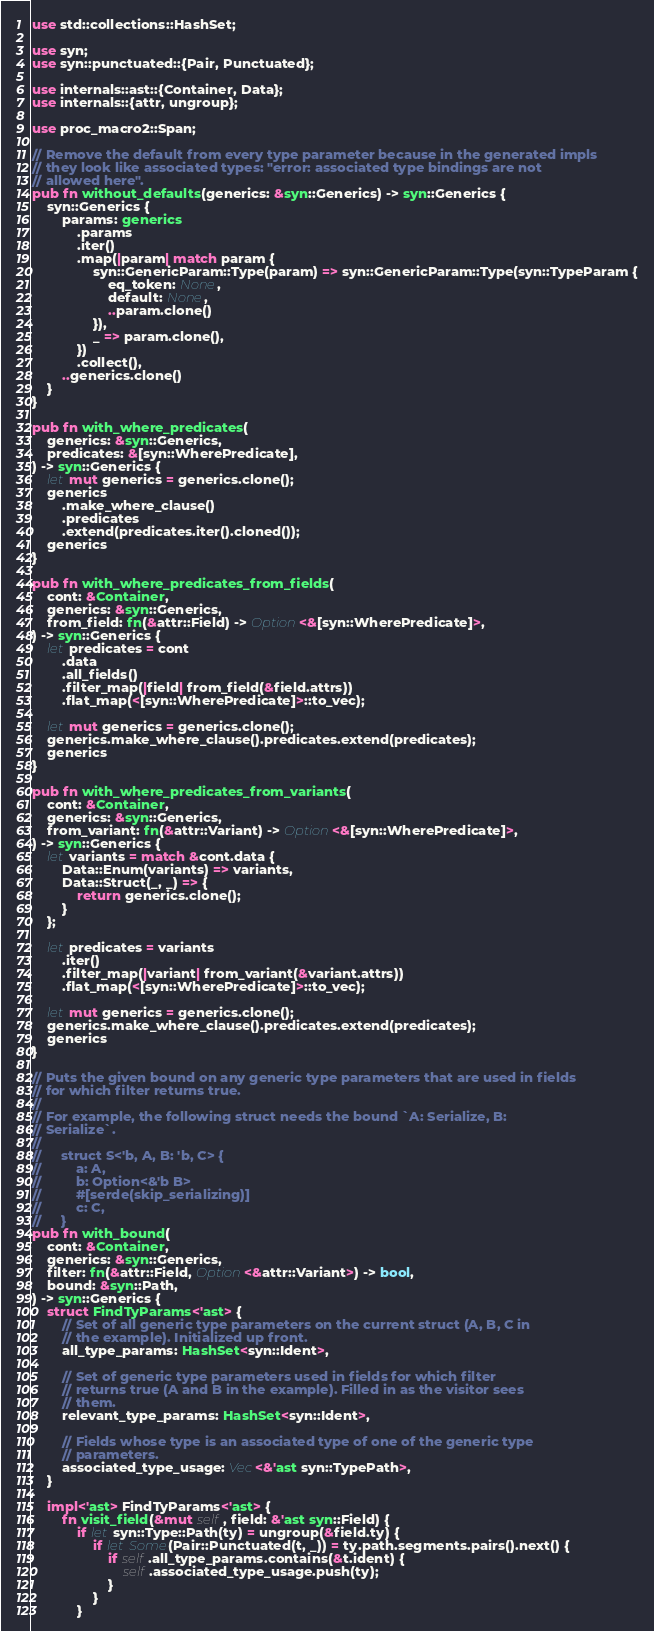Convert code to text. <code><loc_0><loc_0><loc_500><loc_500><_Rust_>use std::collections::HashSet;

use syn;
use syn::punctuated::{Pair, Punctuated};

use internals::ast::{Container, Data};
use internals::{attr, ungroup};

use proc_macro2::Span;

// Remove the default from every type parameter because in the generated impls
// they look like associated types: "error: associated type bindings are not
// allowed here".
pub fn without_defaults(generics: &syn::Generics) -> syn::Generics {
    syn::Generics {
        params: generics
            .params
            .iter()
            .map(|param| match param {
                syn::GenericParam::Type(param) => syn::GenericParam::Type(syn::TypeParam {
                    eq_token: None,
                    default: None,
                    ..param.clone()
                }),
                _ => param.clone(),
            })
            .collect(),
        ..generics.clone()
    }
}

pub fn with_where_predicates(
    generics: &syn::Generics,
    predicates: &[syn::WherePredicate],
) -> syn::Generics {
    let mut generics = generics.clone();
    generics
        .make_where_clause()
        .predicates
        .extend(predicates.iter().cloned());
    generics
}

pub fn with_where_predicates_from_fields(
    cont: &Container,
    generics: &syn::Generics,
    from_field: fn(&attr::Field) -> Option<&[syn::WherePredicate]>,
) -> syn::Generics {
    let predicates = cont
        .data
        .all_fields()
        .filter_map(|field| from_field(&field.attrs))
        .flat_map(<[syn::WherePredicate]>::to_vec);

    let mut generics = generics.clone();
    generics.make_where_clause().predicates.extend(predicates);
    generics
}

pub fn with_where_predicates_from_variants(
    cont: &Container,
    generics: &syn::Generics,
    from_variant: fn(&attr::Variant) -> Option<&[syn::WherePredicate]>,
) -> syn::Generics {
    let variants = match &cont.data {
        Data::Enum(variants) => variants,
        Data::Struct(_, _) => {
            return generics.clone();
        }
    };

    let predicates = variants
        .iter()
        .filter_map(|variant| from_variant(&variant.attrs))
        .flat_map(<[syn::WherePredicate]>::to_vec);

    let mut generics = generics.clone();
    generics.make_where_clause().predicates.extend(predicates);
    generics
}

// Puts the given bound on any generic type parameters that are used in fields
// for which filter returns true.
//
// For example, the following struct needs the bound `A: Serialize, B:
// Serialize`.
//
//     struct S<'b, A, B: 'b, C> {
//         a: A,
//         b: Option<&'b B>
//         #[serde(skip_serializing)]
//         c: C,
//     }
pub fn with_bound(
    cont: &Container,
    generics: &syn::Generics,
    filter: fn(&attr::Field, Option<&attr::Variant>) -> bool,
    bound: &syn::Path,
) -> syn::Generics {
    struct FindTyParams<'ast> {
        // Set of all generic type parameters on the current struct (A, B, C in
        // the example). Initialized up front.
        all_type_params: HashSet<syn::Ident>,

        // Set of generic type parameters used in fields for which filter
        // returns true (A and B in the example). Filled in as the visitor sees
        // them.
        relevant_type_params: HashSet<syn::Ident>,

        // Fields whose type is an associated type of one of the generic type
        // parameters.
        associated_type_usage: Vec<&'ast syn::TypePath>,
    }

    impl<'ast> FindTyParams<'ast> {
        fn visit_field(&mut self, field: &'ast syn::Field) {
            if let syn::Type::Path(ty) = ungroup(&field.ty) {
                if let Some(Pair::Punctuated(t, _)) = ty.path.segments.pairs().next() {
                    if self.all_type_params.contains(&t.ident) {
                        self.associated_type_usage.push(ty);
                    }
                }
            }</code> 